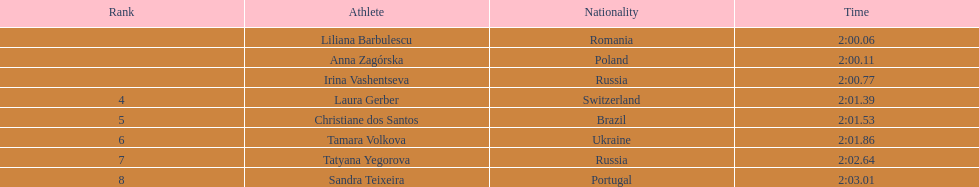Who are all the participants? Liliana Barbulescu, Anna Zagórska, Irina Vashentseva, Laura Gerber, Christiane dos Santos, Tamara Volkova, Tatyana Yegorova, Sandra Teixeira. What were their records in the heat? 2:00.06, 2:00.11, 2:00.77, 2:01.39, 2:01.53, 2:01.86, 2:02.64, 2:03.01. Of these, which is the leading record? 2:00.06. Which participant had this record? Liliana Barbulescu. 